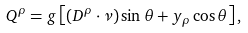<formula> <loc_0><loc_0><loc_500><loc_500>Q ^ { \rho } = g \left [ ( D ^ { \rho } \cdot \nu ) \sin \theta + y _ { \rho } \cos \theta \right ] ,</formula> 